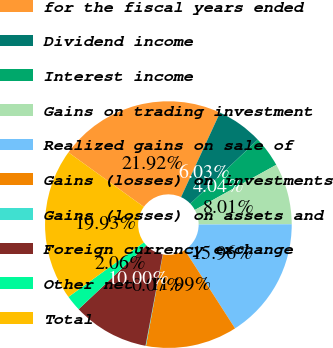Convert chart to OTSL. <chart><loc_0><loc_0><loc_500><loc_500><pie_chart><fcel>for the fiscal years ended<fcel>Dividend income<fcel>Interest income<fcel>Gains on trading investment<fcel>Realized gains on sale of<fcel>Gains (losses) on investments<fcel>Gains (losses) on assets and<fcel>Foreign currency exchange<fcel>Other net<fcel>Total<nl><fcel>21.92%<fcel>6.03%<fcel>4.04%<fcel>8.01%<fcel>15.96%<fcel>11.99%<fcel>0.07%<fcel>10.0%<fcel>2.06%<fcel>19.93%<nl></chart> 